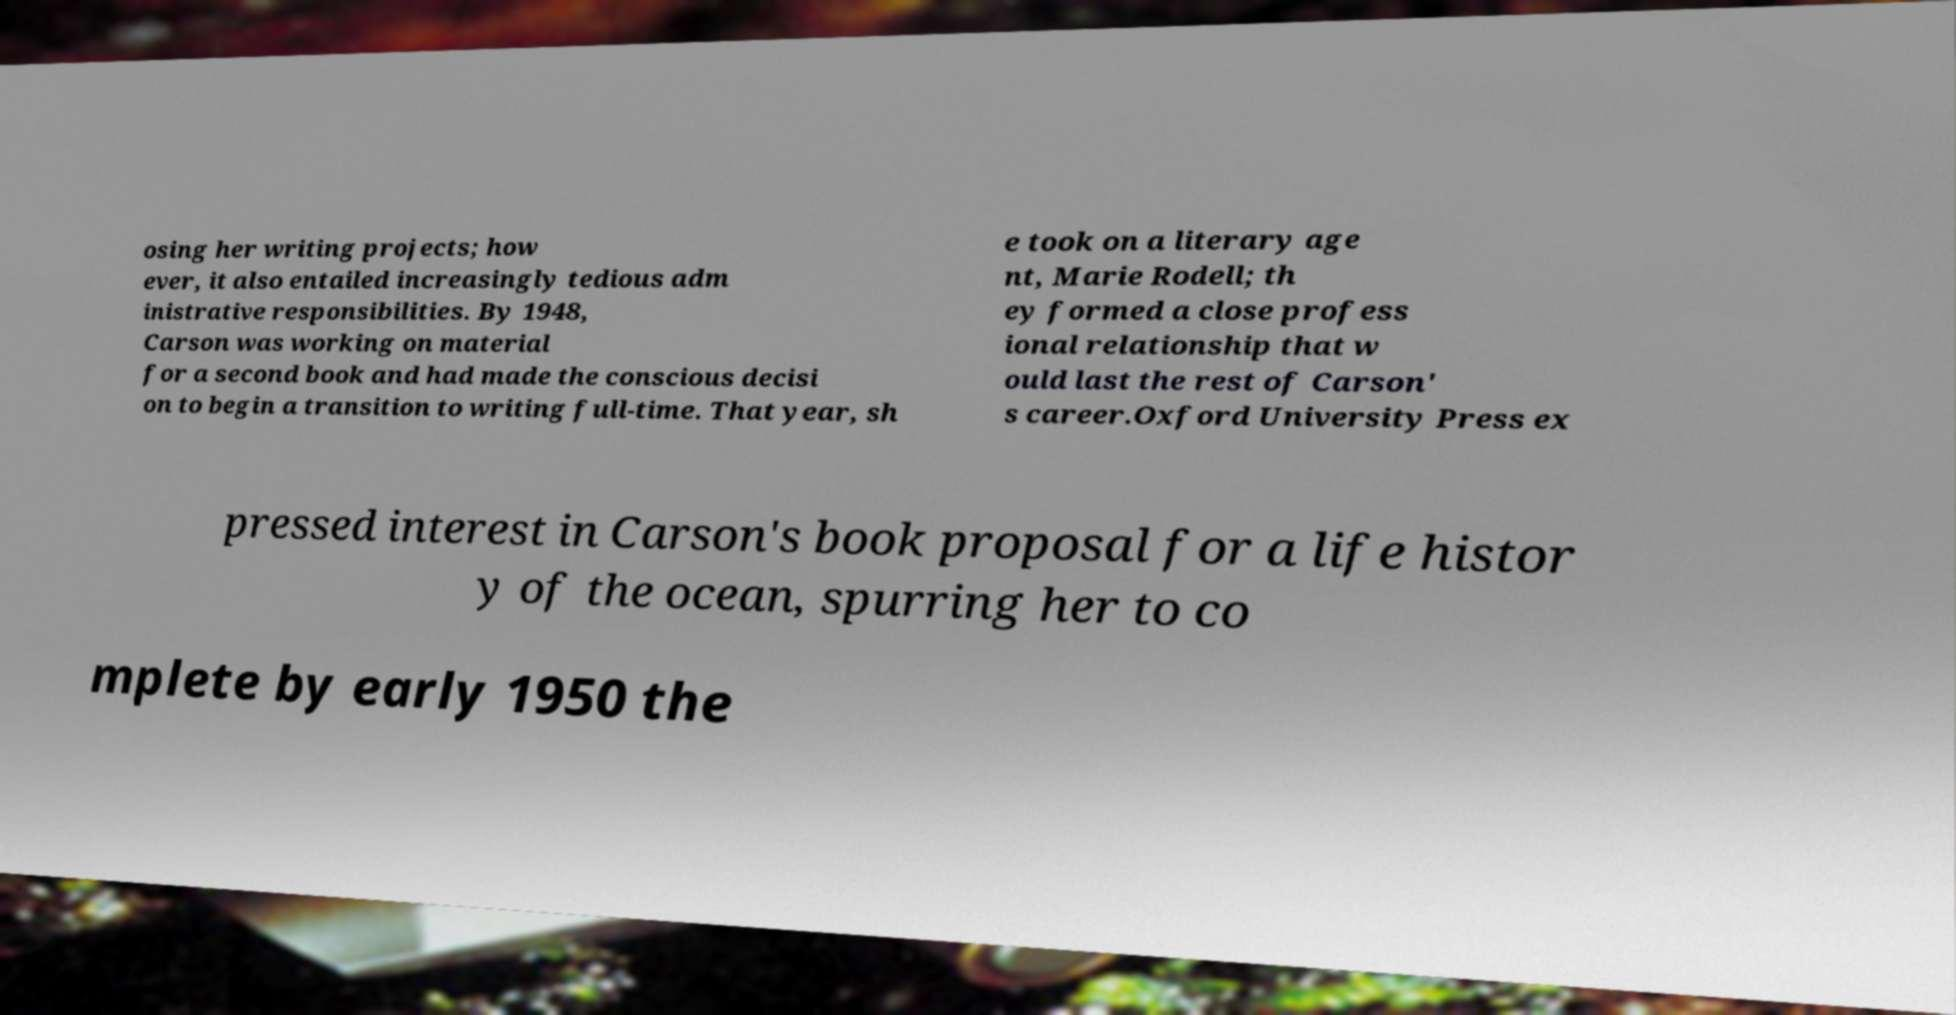There's text embedded in this image that I need extracted. Can you transcribe it verbatim? osing her writing projects; how ever, it also entailed increasingly tedious adm inistrative responsibilities. By 1948, Carson was working on material for a second book and had made the conscious decisi on to begin a transition to writing full-time. That year, sh e took on a literary age nt, Marie Rodell; th ey formed a close profess ional relationship that w ould last the rest of Carson' s career.Oxford University Press ex pressed interest in Carson's book proposal for a life histor y of the ocean, spurring her to co mplete by early 1950 the 